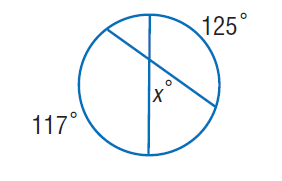Question: Find x.
Choices:
A. 59
B. 117
C. 125
D. 342
Answer with the letter. Answer: A 